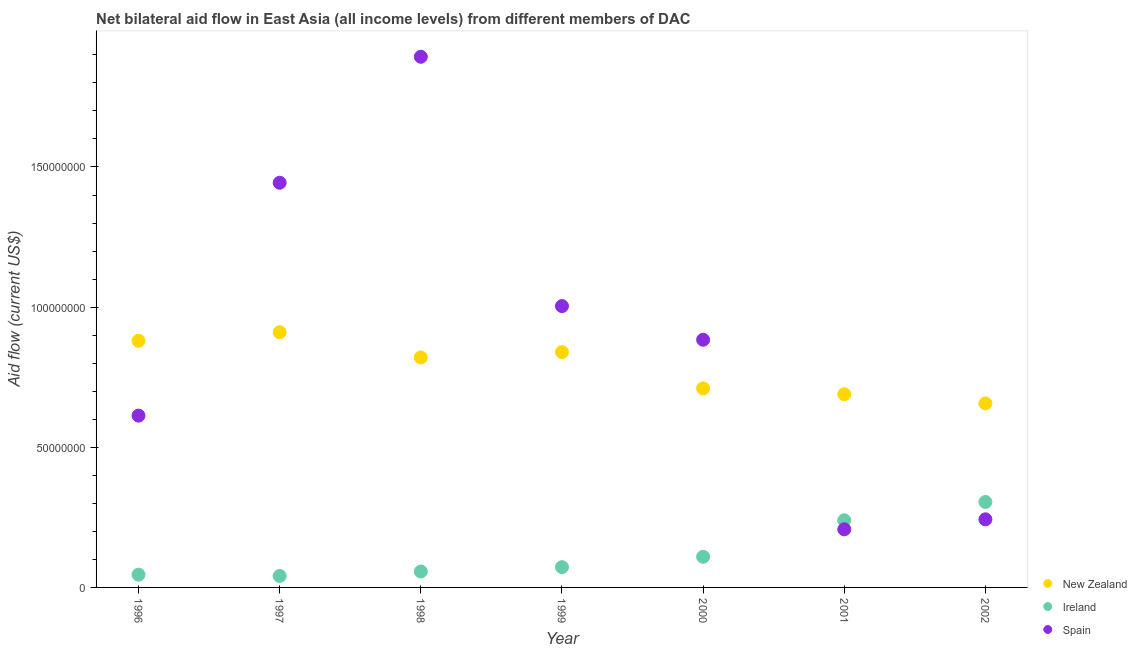What is the amount of aid provided by new zealand in 2001?
Your answer should be very brief. 6.89e+07. Across all years, what is the maximum amount of aid provided by spain?
Provide a succinct answer. 1.89e+08. Across all years, what is the minimum amount of aid provided by ireland?
Provide a short and direct response. 4.09e+06. What is the total amount of aid provided by new zealand in the graph?
Your answer should be compact. 5.51e+08. What is the difference between the amount of aid provided by spain in 2001 and that in 2002?
Give a very brief answer. -3.57e+06. What is the difference between the amount of aid provided by spain in 1997 and the amount of aid provided by ireland in 1996?
Offer a terse response. 1.40e+08. What is the average amount of aid provided by spain per year?
Provide a succinct answer. 8.98e+07. In the year 1997, what is the difference between the amount of aid provided by spain and amount of aid provided by ireland?
Provide a short and direct response. 1.40e+08. What is the ratio of the amount of aid provided by spain in 1999 to that in 2000?
Provide a succinct answer. 1.14. Is the amount of aid provided by ireland in 2000 less than that in 2002?
Ensure brevity in your answer.  Yes. What is the difference between the highest and the second highest amount of aid provided by new zealand?
Your answer should be very brief. 3.05e+06. What is the difference between the highest and the lowest amount of aid provided by ireland?
Your answer should be very brief. 2.64e+07. In how many years, is the amount of aid provided by new zealand greater than the average amount of aid provided by new zealand taken over all years?
Keep it short and to the point. 4. Is it the case that in every year, the sum of the amount of aid provided by new zealand and amount of aid provided by ireland is greater than the amount of aid provided by spain?
Give a very brief answer. No. Is the amount of aid provided by ireland strictly greater than the amount of aid provided by spain over the years?
Ensure brevity in your answer.  No. Is the amount of aid provided by spain strictly less than the amount of aid provided by new zealand over the years?
Your answer should be compact. No. Are the values on the major ticks of Y-axis written in scientific E-notation?
Offer a very short reply. No. Does the graph contain grids?
Offer a very short reply. No. Where does the legend appear in the graph?
Your answer should be compact. Bottom right. How are the legend labels stacked?
Keep it short and to the point. Vertical. What is the title of the graph?
Offer a very short reply. Net bilateral aid flow in East Asia (all income levels) from different members of DAC. Does "New Zealand" appear as one of the legend labels in the graph?
Your answer should be compact. Yes. What is the label or title of the X-axis?
Your response must be concise. Year. What is the Aid flow (current US$) of New Zealand in 1996?
Offer a very short reply. 8.80e+07. What is the Aid flow (current US$) of Ireland in 1996?
Offer a terse response. 4.55e+06. What is the Aid flow (current US$) of Spain in 1996?
Provide a succinct answer. 6.13e+07. What is the Aid flow (current US$) of New Zealand in 1997?
Your answer should be compact. 9.10e+07. What is the Aid flow (current US$) of Ireland in 1997?
Make the answer very short. 4.09e+06. What is the Aid flow (current US$) in Spain in 1997?
Ensure brevity in your answer.  1.44e+08. What is the Aid flow (current US$) of New Zealand in 1998?
Give a very brief answer. 8.20e+07. What is the Aid flow (current US$) in Ireland in 1998?
Provide a short and direct response. 5.68e+06. What is the Aid flow (current US$) of Spain in 1998?
Your response must be concise. 1.89e+08. What is the Aid flow (current US$) of New Zealand in 1999?
Provide a short and direct response. 8.40e+07. What is the Aid flow (current US$) of Ireland in 1999?
Your answer should be compact. 7.23e+06. What is the Aid flow (current US$) in Spain in 1999?
Your answer should be very brief. 1.00e+08. What is the Aid flow (current US$) of New Zealand in 2000?
Make the answer very short. 7.10e+07. What is the Aid flow (current US$) of Ireland in 2000?
Your response must be concise. 1.09e+07. What is the Aid flow (current US$) in Spain in 2000?
Provide a short and direct response. 8.84e+07. What is the Aid flow (current US$) of New Zealand in 2001?
Your response must be concise. 6.89e+07. What is the Aid flow (current US$) of Ireland in 2001?
Provide a succinct answer. 2.40e+07. What is the Aid flow (current US$) of Spain in 2001?
Make the answer very short. 2.07e+07. What is the Aid flow (current US$) in New Zealand in 2002?
Keep it short and to the point. 6.57e+07. What is the Aid flow (current US$) of Ireland in 2002?
Offer a terse response. 3.05e+07. What is the Aid flow (current US$) in Spain in 2002?
Give a very brief answer. 2.43e+07. Across all years, what is the maximum Aid flow (current US$) in New Zealand?
Keep it short and to the point. 9.10e+07. Across all years, what is the maximum Aid flow (current US$) in Ireland?
Keep it short and to the point. 3.05e+07. Across all years, what is the maximum Aid flow (current US$) in Spain?
Offer a terse response. 1.89e+08. Across all years, what is the minimum Aid flow (current US$) of New Zealand?
Your answer should be very brief. 6.57e+07. Across all years, what is the minimum Aid flow (current US$) in Ireland?
Keep it short and to the point. 4.09e+06. Across all years, what is the minimum Aid flow (current US$) of Spain?
Your answer should be compact. 2.07e+07. What is the total Aid flow (current US$) in New Zealand in the graph?
Your answer should be compact. 5.51e+08. What is the total Aid flow (current US$) in Ireland in the graph?
Offer a very short reply. 8.69e+07. What is the total Aid flow (current US$) in Spain in the graph?
Make the answer very short. 6.29e+08. What is the difference between the Aid flow (current US$) in New Zealand in 1996 and that in 1997?
Offer a very short reply. -3.05e+06. What is the difference between the Aid flow (current US$) of Ireland in 1996 and that in 1997?
Provide a short and direct response. 4.60e+05. What is the difference between the Aid flow (current US$) in Spain in 1996 and that in 1997?
Give a very brief answer. -8.31e+07. What is the difference between the Aid flow (current US$) of New Zealand in 1996 and that in 1998?
Make the answer very short. 5.94e+06. What is the difference between the Aid flow (current US$) of Ireland in 1996 and that in 1998?
Provide a short and direct response. -1.13e+06. What is the difference between the Aid flow (current US$) in Spain in 1996 and that in 1998?
Your answer should be very brief. -1.28e+08. What is the difference between the Aid flow (current US$) in New Zealand in 1996 and that in 1999?
Give a very brief answer. 4.04e+06. What is the difference between the Aid flow (current US$) of Ireland in 1996 and that in 1999?
Make the answer very short. -2.68e+06. What is the difference between the Aid flow (current US$) of Spain in 1996 and that in 1999?
Make the answer very short. -3.91e+07. What is the difference between the Aid flow (current US$) in New Zealand in 1996 and that in 2000?
Provide a succinct answer. 1.70e+07. What is the difference between the Aid flow (current US$) of Ireland in 1996 and that in 2000?
Provide a succinct answer. -6.39e+06. What is the difference between the Aid flow (current US$) of Spain in 1996 and that in 2000?
Offer a very short reply. -2.71e+07. What is the difference between the Aid flow (current US$) of New Zealand in 1996 and that in 2001?
Your answer should be compact. 1.91e+07. What is the difference between the Aid flow (current US$) of Ireland in 1996 and that in 2001?
Provide a succinct answer. -1.94e+07. What is the difference between the Aid flow (current US$) of Spain in 1996 and that in 2001?
Make the answer very short. 4.06e+07. What is the difference between the Aid flow (current US$) in New Zealand in 1996 and that in 2002?
Your answer should be compact. 2.23e+07. What is the difference between the Aid flow (current US$) in Ireland in 1996 and that in 2002?
Offer a terse response. -2.59e+07. What is the difference between the Aid flow (current US$) of Spain in 1996 and that in 2002?
Make the answer very short. 3.70e+07. What is the difference between the Aid flow (current US$) of New Zealand in 1997 and that in 1998?
Offer a terse response. 8.99e+06. What is the difference between the Aid flow (current US$) of Ireland in 1997 and that in 1998?
Offer a very short reply. -1.59e+06. What is the difference between the Aid flow (current US$) in Spain in 1997 and that in 1998?
Your response must be concise. -4.49e+07. What is the difference between the Aid flow (current US$) in New Zealand in 1997 and that in 1999?
Provide a succinct answer. 7.09e+06. What is the difference between the Aid flow (current US$) in Ireland in 1997 and that in 1999?
Your response must be concise. -3.14e+06. What is the difference between the Aid flow (current US$) in Spain in 1997 and that in 1999?
Offer a terse response. 4.40e+07. What is the difference between the Aid flow (current US$) in New Zealand in 1997 and that in 2000?
Provide a short and direct response. 2.00e+07. What is the difference between the Aid flow (current US$) of Ireland in 1997 and that in 2000?
Keep it short and to the point. -6.85e+06. What is the difference between the Aid flow (current US$) of Spain in 1997 and that in 2000?
Ensure brevity in your answer.  5.60e+07. What is the difference between the Aid flow (current US$) in New Zealand in 1997 and that in 2001?
Your answer should be very brief. 2.21e+07. What is the difference between the Aid flow (current US$) of Ireland in 1997 and that in 2001?
Make the answer very short. -1.99e+07. What is the difference between the Aid flow (current US$) of Spain in 1997 and that in 2001?
Make the answer very short. 1.24e+08. What is the difference between the Aid flow (current US$) in New Zealand in 1997 and that in 2002?
Ensure brevity in your answer.  2.54e+07. What is the difference between the Aid flow (current US$) of Ireland in 1997 and that in 2002?
Offer a very short reply. -2.64e+07. What is the difference between the Aid flow (current US$) of Spain in 1997 and that in 2002?
Your answer should be compact. 1.20e+08. What is the difference between the Aid flow (current US$) of New Zealand in 1998 and that in 1999?
Keep it short and to the point. -1.90e+06. What is the difference between the Aid flow (current US$) in Ireland in 1998 and that in 1999?
Keep it short and to the point. -1.55e+06. What is the difference between the Aid flow (current US$) in Spain in 1998 and that in 1999?
Offer a very short reply. 8.90e+07. What is the difference between the Aid flow (current US$) in New Zealand in 1998 and that in 2000?
Your answer should be compact. 1.10e+07. What is the difference between the Aid flow (current US$) of Ireland in 1998 and that in 2000?
Your response must be concise. -5.26e+06. What is the difference between the Aid flow (current US$) of Spain in 1998 and that in 2000?
Your answer should be compact. 1.01e+08. What is the difference between the Aid flow (current US$) of New Zealand in 1998 and that in 2001?
Provide a short and direct response. 1.31e+07. What is the difference between the Aid flow (current US$) in Ireland in 1998 and that in 2001?
Your response must be concise. -1.83e+07. What is the difference between the Aid flow (current US$) in Spain in 1998 and that in 2001?
Offer a terse response. 1.69e+08. What is the difference between the Aid flow (current US$) in New Zealand in 1998 and that in 2002?
Offer a very short reply. 1.64e+07. What is the difference between the Aid flow (current US$) in Ireland in 1998 and that in 2002?
Your answer should be compact. -2.48e+07. What is the difference between the Aid flow (current US$) of Spain in 1998 and that in 2002?
Ensure brevity in your answer.  1.65e+08. What is the difference between the Aid flow (current US$) of New Zealand in 1999 and that in 2000?
Offer a terse response. 1.30e+07. What is the difference between the Aid flow (current US$) of Ireland in 1999 and that in 2000?
Provide a short and direct response. -3.71e+06. What is the difference between the Aid flow (current US$) in Spain in 1999 and that in 2000?
Give a very brief answer. 1.20e+07. What is the difference between the Aid flow (current US$) in New Zealand in 1999 and that in 2001?
Your answer should be very brief. 1.50e+07. What is the difference between the Aid flow (current US$) in Ireland in 1999 and that in 2001?
Provide a short and direct response. -1.67e+07. What is the difference between the Aid flow (current US$) in Spain in 1999 and that in 2001?
Offer a very short reply. 7.96e+07. What is the difference between the Aid flow (current US$) of New Zealand in 1999 and that in 2002?
Keep it short and to the point. 1.83e+07. What is the difference between the Aid flow (current US$) of Ireland in 1999 and that in 2002?
Keep it short and to the point. -2.33e+07. What is the difference between the Aid flow (current US$) in Spain in 1999 and that in 2002?
Offer a very short reply. 7.61e+07. What is the difference between the Aid flow (current US$) of New Zealand in 2000 and that in 2001?
Offer a very short reply. 2.07e+06. What is the difference between the Aid flow (current US$) in Ireland in 2000 and that in 2001?
Make the answer very short. -1.30e+07. What is the difference between the Aid flow (current US$) in Spain in 2000 and that in 2001?
Provide a succinct answer. 6.76e+07. What is the difference between the Aid flow (current US$) in New Zealand in 2000 and that in 2002?
Your answer should be very brief. 5.33e+06. What is the difference between the Aid flow (current US$) in Ireland in 2000 and that in 2002?
Ensure brevity in your answer.  -1.96e+07. What is the difference between the Aid flow (current US$) in Spain in 2000 and that in 2002?
Your response must be concise. 6.41e+07. What is the difference between the Aid flow (current US$) of New Zealand in 2001 and that in 2002?
Your answer should be compact. 3.26e+06. What is the difference between the Aid flow (current US$) of Ireland in 2001 and that in 2002?
Your response must be concise. -6.53e+06. What is the difference between the Aid flow (current US$) of Spain in 2001 and that in 2002?
Provide a succinct answer. -3.57e+06. What is the difference between the Aid flow (current US$) of New Zealand in 1996 and the Aid flow (current US$) of Ireland in 1997?
Keep it short and to the point. 8.39e+07. What is the difference between the Aid flow (current US$) of New Zealand in 1996 and the Aid flow (current US$) of Spain in 1997?
Keep it short and to the point. -5.64e+07. What is the difference between the Aid flow (current US$) of Ireland in 1996 and the Aid flow (current US$) of Spain in 1997?
Ensure brevity in your answer.  -1.40e+08. What is the difference between the Aid flow (current US$) of New Zealand in 1996 and the Aid flow (current US$) of Ireland in 1998?
Provide a short and direct response. 8.23e+07. What is the difference between the Aid flow (current US$) of New Zealand in 1996 and the Aid flow (current US$) of Spain in 1998?
Offer a terse response. -1.01e+08. What is the difference between the Aid flow (current US$) of Ireland in 1996 and the Aid flow (current US$) of Spain in 1998?
Keep it short and to the point. -1.85e+08. What is the difference between the Aid flow (current US$) of New Zealand in 1996 and the Aid flow (current US$) of Ireland in 1999?
Ensure brevity in your answer.  8.08e+07. What is the difference between the Aid flow (current US$) of New Zealand in 1996 and the Aid flow (current US$) of Spain in 1999?
Offer a very short reply. -1.24e+07. What is the difference between the Aid flow (current US$) in Ireland in 1996 and the Aid flow (current US$) in Spain in 1999?
Keep it short and to the point. -9.58e+07. What is the difference between the Aid flow (current US$) of New Zealand in 1996 and the Aid flow (current US$) of Ireland in 2000?
Ensure brevity in your answer.  7.70e+07. What is the difference between the Aid flow (current US$) of New Zealand in 1996 and the Aid flow (current US$) of Spain in 2000?
Offer a terse response. -3.70e+05. What is the difference between the Aid flow (current US$) of Ireland in 1996 and the Aid flow (current US$) of Spain in 2000?
Ensure brevity in your answer.  -8.38e+07. What is the difference between the Aid flow (current US$) in New Zealand in 1996 and the Aid flow (current US$) in Ireland in 2001?
Your answer should be compact. 6.40e+07. What is the difference between the Aid flow (current US$) of New Zealand in 1996 and the Aid flow (current US$) of Spain in 2001?
Make the answer very short. 6.73e+07. What is the difference between the Aid flow (current US$) of Ireland in 1996 and the Aid flow (current US$) of Spain in 2001?
Ensure brevity in your answer.  -1.62e+07. What is the difference between the Aid flow (current US$) of New Zealand in 1996 and the Aid flow (current US$) of Ireland in 2002?
Keep it short and to the point. 5.75e+07. What is the difference between the Aid flow (current US$) of New Zealand in 1996 and the Aid flow (current US$) of Spain in 2002?
Give a very brief answer. 6.37e+07. What is the difference between the Aid flow (current US$) of Ireland in 1996 and the Aid flow (current US$) of Spain in 2002?
Keep it short and to the point. -1.98e+07. What is the difference between the Aid flow (current US$) in New Zealand in 1997 and the Aid flow (current US$) in Ireland in 1998?
Make the answer very short. 8.54e+07. What is the difference between the Aid flow (current US$) of New Zealand in 1997 and the Aid flow (current US$) of Spain in 1998?
Your answer should be compact. -9.83e+07. What is the difference between the Aid flow (current US$) of Ireland in 1997 and the Aid flow (current US$) of Spain in 1998?
Keep it short and to the point. -1.85e+08. What is the difference between the Aid flow (current US$) in New Zealand in 1997 and the Aid flow (current US$) in Ireland in 1999?
Your answer should be compact. 8.38e+07. What is the difference between the Aid flow (current US$) in New Zealand in 1997 and the Aid flow (current US$) in Spain in 1999?
Provide a succinct answer. -9.33e+06. What is the difference between the Aid flow (current US$) in Ireland in 1997 and the Aid flow (current US$) in Spain in 1999?
Ensure brevity in your answer.  -9.63e+07. What is the difference between the Aid flow (current US$) in New Zealand in 1997 and the Aid flow (current US$) in Ireland in 2000?
Provide a short and direct response. 8.01e+07. What is the difference between the Aid flow (current US$) of New Zealand in 1997 and the Aid flow (current US$) of Spain in 2000?
Offer a very short reply. 2.68e+06. What is the difference between the Aid flow (current US$) in Ireland in 1997 and the Aid flow (current US$) in Spain in 2000?
Offer a very short reply. -8.43e+07. What is the difference between the Aid flow (current US$) of New Zealand in 1997 and the Aid flow (current US$) of Ireland in 2001?
Give a very brief answer. 6.71e+07. What is the difference between the Aid flow (current US$) in New Zealand in 1997 and the Aid flow (current US$) in Spain in 2001?
Make the answer very short. 7.03e+07. What is the difference between the Aid flow (current US$) of Ireland in 1997 and the Aid flow (current US$) of Spain in 2001?
Your response must be concise. -1.66e+07. What is the difference between the Aid flow (current US$) in New Zealand in 1997 and the Aid flow (current US$) in Ireland in 2002?
Keep it short and to the point. 6.06e+07. What is the difference between the Aid flow (current US$) of New Zealand in 1997 and the Aid flow (current US$) of Spain in 2002?
Your answer should be compact. 6.67e+07. What is the difference between the Aid flow (current US$) in Ireland in 1997 and the Aid flow (current US$) in Spain in 2002?
Provide a short and direct response. -2.02e+07. What is the difference between the Aid flow (current US$) in New Zealand in 1998 and the Aid flow (current US$) in Ireland in 1999?
Provide a short and direct response. 7.48e+07. What is the difference between the Aid flow (current US$) of New Zealand in 1998 and the Aid flow (current US$) of Spain in 1999?
Give a very brief answer. -1.83e+07. What is the difference between the Aid flow (current US$) in Ireland in 1998 and the Aid flow (current US$) in Spain in 1999?
Your response must be concise. -9.47e+07. What is the difference between the Aid flow (current US$) of New Zealand in 1998 and the Aid flow (current US$) of Ireland in 2000?
Give a very brief answer. 7.11e+07. What is the difference between the Aid flow (current US$) of New Zealand in 1998 and the Aid flow (current US$) of Spain in 2000?
Your answer should be very brief. -6.31e+06. What is the difference between the Aid flow (current US$) of Ireland in 1998 and the Aid flow (current US$) of Spain in 2000?
Your answer should be very brief. -8.27e+07. What is the difference between the Aid flow (current US$) in New Zealand in 1998 and the Aid flow (current US$) in Ireland in 2001?
Your answer should be very brief. 5.81e+07. What is the difference between the Aid flow (current US$) of New Zealand in 1998 and the Aid flow (current US$) of Spain in 2001?
Keep it short and to the point. 6.13e+07. What is the difference between the Aid flow (current US$) of Ireland in 1998 and the Aid flow (current US$) of Spain in 2001?
Give a very brief answer. -1.50e+07. What is the difference between the Aid flow (current US$) in New Zealand in 1998 and the Aid flow (current US$) in Ireland in 2002?
Your response must be concise. 5.16e+07. What is the difference between the Aid flow (current US$) in New Zealand in 1998 and the Aid flow (current US$) in Spain in 2002?
Make the answer very short. 5.78e+07. What is the difference between the Aid flow (current US$) in Ireland in 1998 and the Aid flow (current US$) in Spain in 2002?
Keep it short and to the point. -1.86e+07. What is the difference between the Aid flow (current US$) of New Zealand in 1999 and the Aid flow (current US$) of Ireland in 2000?
Provide a short and direct response. 7.30e+07. What is the difference between the Aid flow (current US$) in New Zealand in 1999 and the Aid flow (current US$) in Spain in 2000?
Provide a succinct answer. -4.41e+06. What is the difference between the Aid flow (current US$) in Ireland in 1999 and the Aid flow (current US$) in Spain in 2000?
Give a very brief answer. -8.11e+07. What is the difference between the Aid flow (current US$) in New Zealand in 1999 and the Aid flow (current US$) in Ireland in 2001?
Provide a succinct answer. 6.00e+07. What is the difference between the Aid flow (current US$) of New Zealand in 1999 and the Aid flow (current US$) of Spain in 2001?
Provide a succinct answer. 6.32e+07. What is the difference between the Aid flow (current US$) in Ireland in 1999 and the Aid flow (current US$) in Spain in 2001?
Provide a short and direct response. -1.35e+07. What is the difference between the Aid flow (current US$) in New Zealand in 1999 and the Aid flow (current US$) in Ireland in 2002?
Your answer should be very brief. 5.35e+07. What is the difference between the Aid flow (current US$) in New Zealand in 1999 and the Aid flow (current US$) in Spain in 2002?
Offer a very short reply. 5.96e+07. What is the difference between the Aid flow (current US$) of Ireland in 1999 and the Aid flow (current US$) of Spain in 2002?
Offer a terse response. -1.71e+07. What is the difference between the Aid flow (current US$) of New Zealand in 2000 and the Aid flow (current US$) of Ireland in 2001?
Ensure brevity in your answer.  4.70e+07. What is the difference between the Aid flow (current US$) of New Zealand in 2000 and the Aid flow (current US$) of Spain in 2001?
Your answer should be compact. 5.03e+07. What is the difference between the Aid flow (current US$) of Ireland in 2000 and the Aid flow (current US$) of Spain in 2001?
Keep it short and to the point. -9.79e+06. What is the difference between the Aid flow (current US$) in New Zealand in 2000 and the Aid flow (current US$) in Ireland in 2002?
Your response must be concise. 4.05e+07. What is the difference between the Aid flow (current US$) of New Zealand in 2000 and the Aid flow (current US$) of Spain in 2002?
Your answer should be compact. 4.67e+07. What is the difference between the Aid flow (current US$) of Ireland in 2000 and the Aid flow (current US$) of Spain in 2002?
Your answer should be compact. -1.34e+07. What is the difference between the Aid flow (current US$) of New Zealand in 2001 and the Aid flow (current US$) of Ireland in 2002?
Ensure brevity in your answer.  3.84e+07. What is the difference between the Aid flow (current US$) in New Zealand in 2001 and the Aid flow (current US$) in Spain in 2002?
Keep it short and to the point. 4.46e+07. What is the difference between the Aid flow (current US$) of Ireland in 2001 and the Aid flow (current US$) of Spain in 2002?
Provide a short and direct response. -3.40e+05. What is the average Aid flow (current US$) in New Zealand per year?
Your answer should be very brief. 7.87e+07. What is the average Aid flow (current US$) in Ireland per year?
Provide a succinct answer. 1.24e+07. What is the average Aid flow (current US$) in Spain per year?
Your answer should be compact. 8.98e+07. In the year 1996, what is the difference between the Aid flow (current US$) in New Zealand and Aid flow (current US$) in Ireland?
Your response must be concise. 8.34e+07. In the year 1996, what is the difference between the Aid flow (current US$) in New Zealand and Aid flow (current US$) in Spain?
Your answer should be compact. 2.67e+07. In the year 1996, what is the difference between the Aid flow (current US$) of Ireland and Aid flow (current US$) of Spain?
Keep it short and to the point. -5.67e+07. In the year 1997, what is the difference between the Aid flow (current US$) of New Zealand and Aid flow (current US$) of Ireland?
Your answer should be compact. 8.70e+07. In the year 1997, what is the difference between the Aid flow (current US$) of New Zealand and Aid flow (current US$) of Spain?
Make the answer very short. -5.33e+07. In the year 1997, what is the difference between the Aid flow (current US$) in Ireland and Aid flow (current US$) in Spain?
Give a very brief answer. -1.40e+08. In the year 1998, what is the difference between the Aid flow (current US$) in New Zealand and Aid flow (current US$) in Ireland?
Keep it short and to the point. 7.64e+07. In the year 1998, what is the difference between the Aid flow (current US$) in New Zealand and Aid flow (current US$) in Spain?
Keep it short and to the point. -1.07e+08. In the year 1998, what is the difference between the Aid flow (current US$) of Ireland and Aid flow (current US$) of Spain?
Give a very brief answer. -1.84e+08. In the year 1999, what is the difference between the Aid flow (current US$) of New Zealand and Aid flow (current US$) of Ireland?
Give a very brief answer. 7.67e+07. In the year 1999, what is the difference between the Aid flow (current US$) of New Zealand and Aid flow (current US$) of Spain?
Your answer should be very brief. -1.64e+07. In the year 1999, what is the difference between the Aid flow (current US$) in Ireland and Aid flow (current US$) in Spain?
Keep it short and to the point. -9.31e+07. In the year 2000, what is the difference between the Aid flow (current US$) of New Zealand and Aid flow (current US$) of Ireland?
Your response must be concise. 6.01e+07. In the year 2000, what is the difference between the Aid flow (current US$) of New Zealand and Aid flow (current US$) of Spain?
Give a very brief answer. -1.74e+07. In the year 2000, what is the difference between the Aid flow (current US$) in Ireland and Aid flow (current US$) in Spain?
Offer a very short reply. -7.74e+07. In the year 2001, what is the difference between the Aid flow (current US$) in New Zealand and Aid flow (current US$) in Ireland?
Offer a terse response. 4.50e+07. In the year 2001, what is the difference between the Aid flow (current US$) in New Zealand and Aid flow (current US$) in Spain?
Ensure brevity in your answer.  4.82e+07. In the year 2001, what is the difference between the Aid flow (current US$) in Ireland and Aid flow (current US$) in Spain?
Your response must be concise. 3.23e+06. In the year 2002, what is the difference between the Aid flow (current US$) in New Zealand and Aid flow (current US$) in Ireland?
Offer a terse response. 3.52e+07. In the year 2002, what is the difference between the Aid flow (current US$) in New Zealand and Aid flow (current US$) in Spain?
Provide a succinct answer. 4.14e+07. In the year 2002, what is the difference between the Aid flow (current US$) of Ireland and Aid flow (current US$) of Spain?
Keep it short and to the point. 6.19e+06. What is the ratio of the Aid flow (current US$) in New Zealand in 1996 to that in 1997?
Keep it short and to the point. 0.97. What is the ratio of the Aid flow (current US$) in Ireland in 1996 to that in 1997?
Make the answer very short. 1.11. What is the ratio of the Aid flow (current US$) of Spain in 1996 to that in 1997?
Provide a succinct answer. 0.42. What is the ratio of the Aid flow (current US$) of New Zealand in 1996 to that in 1998?
Offer a very short reply. 1.07. What is the ratio of the Aid flow (current US$) in Ireland in 1996 to that in 1998?
Provide a short and direct response. 0.8. What is the ratio of the Aid flow (current US$) in Spain in 1996 to that in 1998?
Provide a succinct answer. 0.32. What is the ratio of the Aid flow (current US$) of New Zealand in 1996 to that in 1999?
Keep it short and to the point. 1.05. What is the ratio of the Aid flow (current US$) of Ireland in 1996 to that in 1999?
Your response must be concise. 0.63. What is the ratio of the Aid flow (current US$) of Spain in 1996 to that in 1999?
Keep it short and to the point. 0.61. What is the ratio of the Aid flow (current US$) of New Zealand in 1996 to that in 2000?
Provide a short and direct response. 1.24. What is the ratio of the Aid flow (current US$) in Ireland in 1996 to that in 2000?
Provide a short and direct response. 0.42. What is the ratio of the Aid flow (current US$) of Spain in 1996 to that in 2000?
Your answer should be compact. 0.69. What is the ratio of the Aid flow (current US$) in New Zealand in 1996 to that in 2001?
Keep it short and to the point. 1.28. What is the ratio of the Aid flow (current US$) in Ireland in 1996 to that in 2001?
Keep it short and to the point. 0.19. What is the ratio of the Aid flow (current US$) of Spain in 1996 to that in 2001?
Ensure brevity in your answer.  2.96. What is the ratio of the Aid flow (current US$) in New Zealand in 1996 to that in 2002?
Keep it short and to the point. 1.34. What is the ratio of the Aid flow (current US$) of Ireland in 1996 to that in 2002?
Your answer should be compact. 0.15. What is the ratio of the Aid flow (current US$) in Spain in 1996 to that in 2002?
Make the answer very short. 2.52. What is the ratio of the Aid flow (current US$) of New Zealand in 1997 to that in 1998?
Keep it short and to the point. 1.11. What is the ratio of the Aid flow (current US$) of Ireland in 1997 to that in 1998?
Your answer should be very brief. 0.72. What is the ratio of the Aid flow (current US$) in Spain in 1997 to that in 1998?
Your answer should be compact. 0.76. What is the ratio of the Aid flow (current US$) of New Zealand in 1997 to that in 1999?
Make the answer very short. 1.08. What is the ratio of the Aid flow (current US$) of Ireland in 1997 to that in 1999?
Your answer should be very brief. 0.57. What is the ratio of the Aid flow (current US$) in Spain in 1997 to that in 1999?
Ensure brevity in your answer.  1.44. What is the ratio of the Aid flow (current US$) in New Zealand in 1997 to that in 2000?
Make the answer very short. 1.28. What is the ratio of the Aid flow (current US$) in Ireland in 1997 to that in 2000?
Your answer should be compact. 0.37. What is the ratio of the Aid flow (current US$) in Spain in 1997 to that in 2000?
Provide a succinct answer. 1.63. What is the ratio of the Aid flow (current US$) in New Zealand in 1997 to that in 2001?
Provide a short and direct response. 1.32. What is the ratio of the Aid flow (current US$) of Ireland in 1997 to that in 2001?
Provide a succinct answer. 0.17. What is the ratio of the Aid flow (current US$) of Spain in 1997 to that in 2001?
Provide a short and direct response. 6.96. What is the ratio of the Aid flow (current US$) of New Zealand in 1997 to that in 2002?
Your answer should be very brief. 1.39. What is the ratio of the Aid flow (current US$) in Ireland in 1997 to that in 2002?
Make the answer very short. 0.13. What is the ratio of the Aid flow (current US$) in Spain in 1997 to that in 2002?
Provide a short and direct response. 5.94. What is the ratio of the Aid flow (current US$) of New Zealand in 1998 to that in 1999?
Your answer should be compact. 0.98. What is the ratio of the Aid flow (current US$) of Ireland in 1998 to that in 1999?
Keep it short and to the point. 0.79. What is the ratio of the Aid flow (current US$) in Spain in 1998 to that in 1999?
Offer a very short reply. 1.89. What is the ratio of the Aid flow (current US$) of New Zealand in 1998 to that in 2000?
Ensure brevity in your answer.  1.16. What is the ratio of the Aid flow (current US$) of Ireland in 1998 to that in 2000?
Offer a very short reply. 0.52. What is the ratio of the Aid flow (current US$) in Spain in 1998 to that in 2000?
Your response must be concise. 2.14. What is the ratio of the Aid flow (current US$) in New Zealand in 1998 to that in 2001?
Your answer should be very brief. 1.19. What is the ratio of the Aid flow (current US$) of Ireland in 1998 to that in 2001?
Offer a terse response. 0.24. What is the ratio of the Aid flow (current US$) in Spain in 1998 to that in 2001?
Provide a short and direct response. 9.13. What is the ratio of the Aid flow (current US$) of New Zealand in 1998 to that in 2002?
Offer a terse response. 1.25. What is the ratio of the Aid flow (current US$) of Ireland in 1998 to that in 2002?
Keep it short and to the point. 0.19. What is the ratio of the Aid flow (current US$) of Spain in 1998 to that in 2002?
Your answer should be compact. 7.79. What is the ratio of the Aid flow (current US$) in New Zealand in 1999 to that in 2000?
Give a very brief answer. 1.18. What is the ratio of the Aid flow (current US$) of Ireland in 1999 to that in 2000?
Make the answer very short. 0.66. What is the ratio of the Aid flow (current US$) in Spain in 1999 to that in 2000?
Your answer should be compact. 1.14. What is the ratio of the Aid flow (current US$) in New Zealand in 1999 to that in 2001?
Your answer should be compact. 1.22. What is the ratio of the Aid flow (current US$) in Ireland in 1999 to that in 2001?
Keep it short and to the point. 0.3. What is the ratio of the Aid flow (current US$) of Spain in 1999 to that in 2001?
Your answer should be very brief. 4.84. What is the ratio of the Aid flow (current US$) in New Zealand in 1999 to that in 2002?
Offer a very short reply. 1.28. What is the ratio of the Aid flow (current US$) in Ireland in 1999 to that in 2002?
Your response must be concise. 0.24. What is the ratio of the Aid flow (current US$) of Spain in 1999 to that in 2002?
Your response must be concise. 4.13. What is the ratio of the Aid flow (current US$) of New Zealand in 2000 to that in 2001?
Ensure brevity in your answer.  1.03. What is the ratio of the Aid flow (current US$) in Ireland in 2000 to that in 2001?
Make the answer very short. 0.46. What is the ratio of the Aid flow (current US$) in Spain in 2000 to that in 2001?
Ensure brevity in your answer.  4.26. What is the ratio of the Aid flow (current US$) in New Zealand in 2000 to that in 2002?
Offer a very short reply. 1.08. What is the ratio of the Aid flow (current US$) of Ireland in 2000 to that in 2002?
Ensure brevity in your answer.  0.36. What is the ratio of the Aid flow (current US$) of Spain in 2000 to that in 2002?
Give a very brief answer. 3.64. What is the ratio of the Aid flow (current US$) in New Zealand in 2001 to that in 2002?
Your answer should be very brief. 1.05. What is the ratio of the Aid flow (current US$) of Ireland in 2001 to that in 2002?
Your response must be concise. 0.79. What is the ratio of the Aid flow (current US$) of Spain in 2001 to that in 2002?
Your response must be concise. 0.85. What is the difference between the highest and the second highest Aid flow (current US$) in New Zealand?
Offer a terse response. 3.05e+06. What is the difference between the highest and the second highest Aid flow (current US$) of Ireland?
Offer a terse response. 6.53e+06. What is the difference between the highest and the second highest Aid flow (current US$) in Spain?
Offer a very short reply. 4.49e+07. What is the difference between the highest and the lowest Aid flow (current US$) of New Zealand?
Your answer should be very brief. 2.54e+07. What is the difference between the highest and the lowest Aid flow (current US$) of Ireland?
Make the answer very short. 2.64e+07. What is the difference between the highest and the lowest Aid flow (current US$) in Spain?
Your answer should be compact. 1.69e+08. 